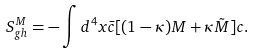Convert formula to latex. <formula><loc_0><loc_0><loc_500><loc_500>S _ { g h } ^ { M } = - \int d ^ { 4 } x \bar { c } [ ( 1 - \kappa ) M + \kappa \tilde { M } ] c .</formula> 